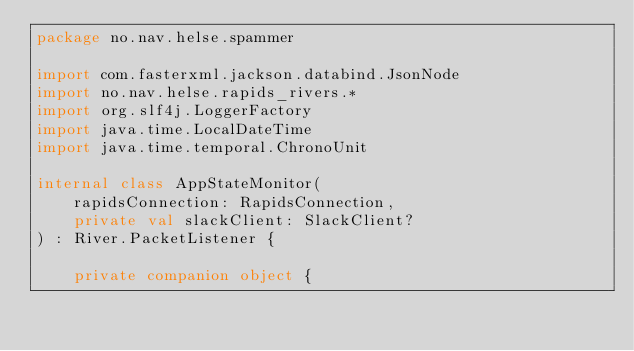Convert code to text. <code><loc_0><loc_0><loc_500><loc_500><_Kotlin_>package no.nav.helse.spammer

import com.fasterxml.jackson.databind.JsonNode
import no.nav.helse.rapids_rivers.*
import org.slf4j.LoggerFactory
import java.time.LocalDateTime
import java.time.temporal.ChronoUnit

internal class AppStateMonitor(
    rapidsConnection: RapidsConnection,
    private val slackClient: SlackClient?
) : River.PacketListener {

    private companion object {</code> 